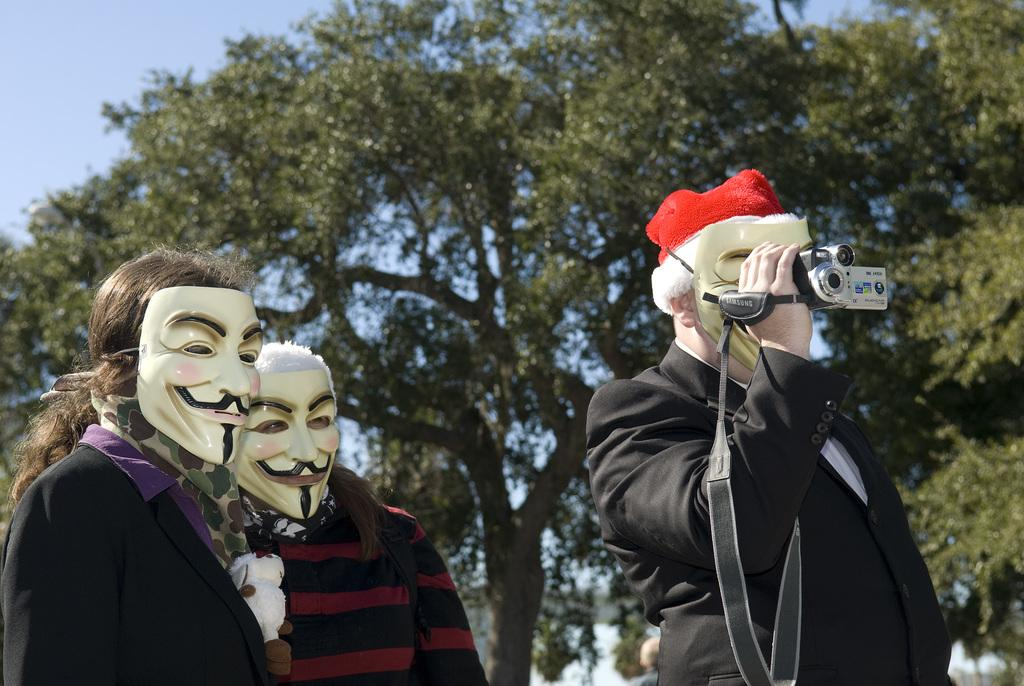How many people are in the image? There are three persons in the image. What is one person doing in the image? One person is holding a camera in their hands. What can be seen in the background of the image? There are trees in the background of the image. What type of force is being applied to the camera in the image? There is no indication of any force being applied to the camera in the image; it is simply being held by one of the persons. How many people are part of the crowd in the image? There is no crowd present in the image; it features three individuals. 